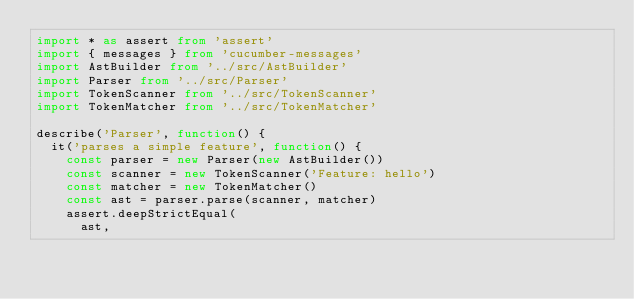Convert code to text. <code><loc_0><loc_0><loc_500><loc_500><_TypeScript_>import * as assert from 'assert'
import { messages } from 'cucumber-messages'
import AstBuilder from '../src/AstBuilder'
import Parser from '../src/Parser'
import TokenScanner from '../src/TokenScanner'
import TokenMatcher from '../src/TokenMatcher'

describe('Parser', function() {
  it('parses a simple feature', function() {
    const parser = new Parser(new AstBuilder())
    const scanner = new TokenScanner('Feature: hello')
    const matcher = new TokenMatcher()
    const ast = parser.parse(scanner, matcher)
    assert.deepStrictEqual(
      ast,</code> 